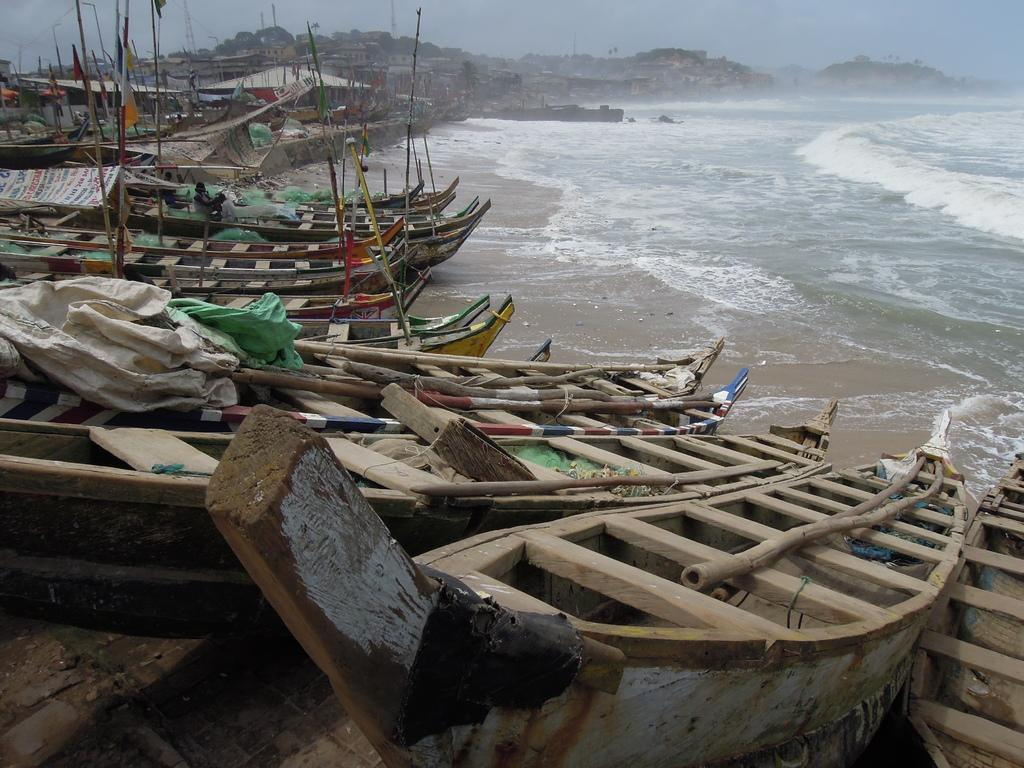What type of vehicles can be seen in the image? There are boats in the image. What decorative elements are present on the boats? There are flags in the image. What natural element is visible in the image? There is water visible in the image. What can be seen in the background of the image? There are buildings in the background of the image. Where are the cushions placed in the image? There are no cushions present in the image. What type of waves can be seen in the image? There are no waves visible in the image; it shows still water. 